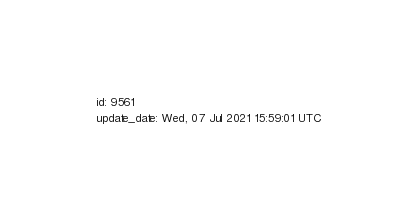<code> <loc_0><loc_0><loc_500><loc_500><_YAML_>id: 9561
update_date: Wed, 07 Jul 2021 15:59:01 UTC
</code> 